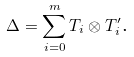<formula> <loc_0><loc_0><loc_500><loc_500>\Delta = \sum _ { i = 0 } ^ { m } T _ { i } \otimes T _ { i } ^ { \prime } \text {.}</formula> 